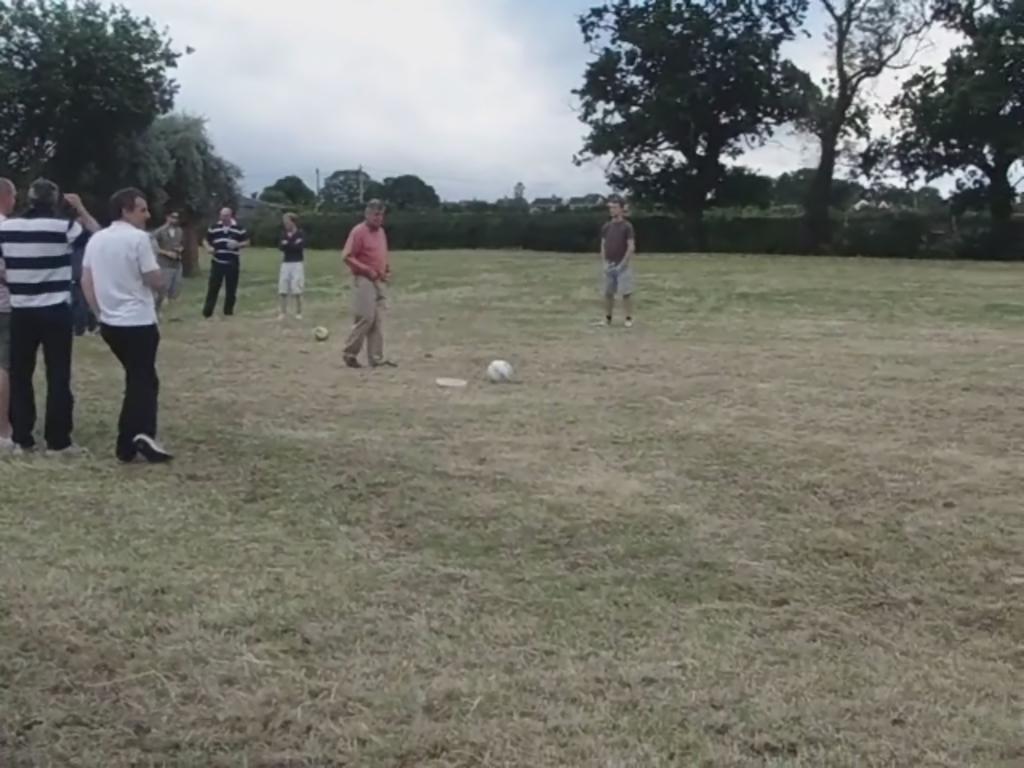Describe this image in one or two sentences. In the image there are many men standing in the back with footballs in front of them on the grassland and in the back there are back there are trees all over the place and above its sky. 